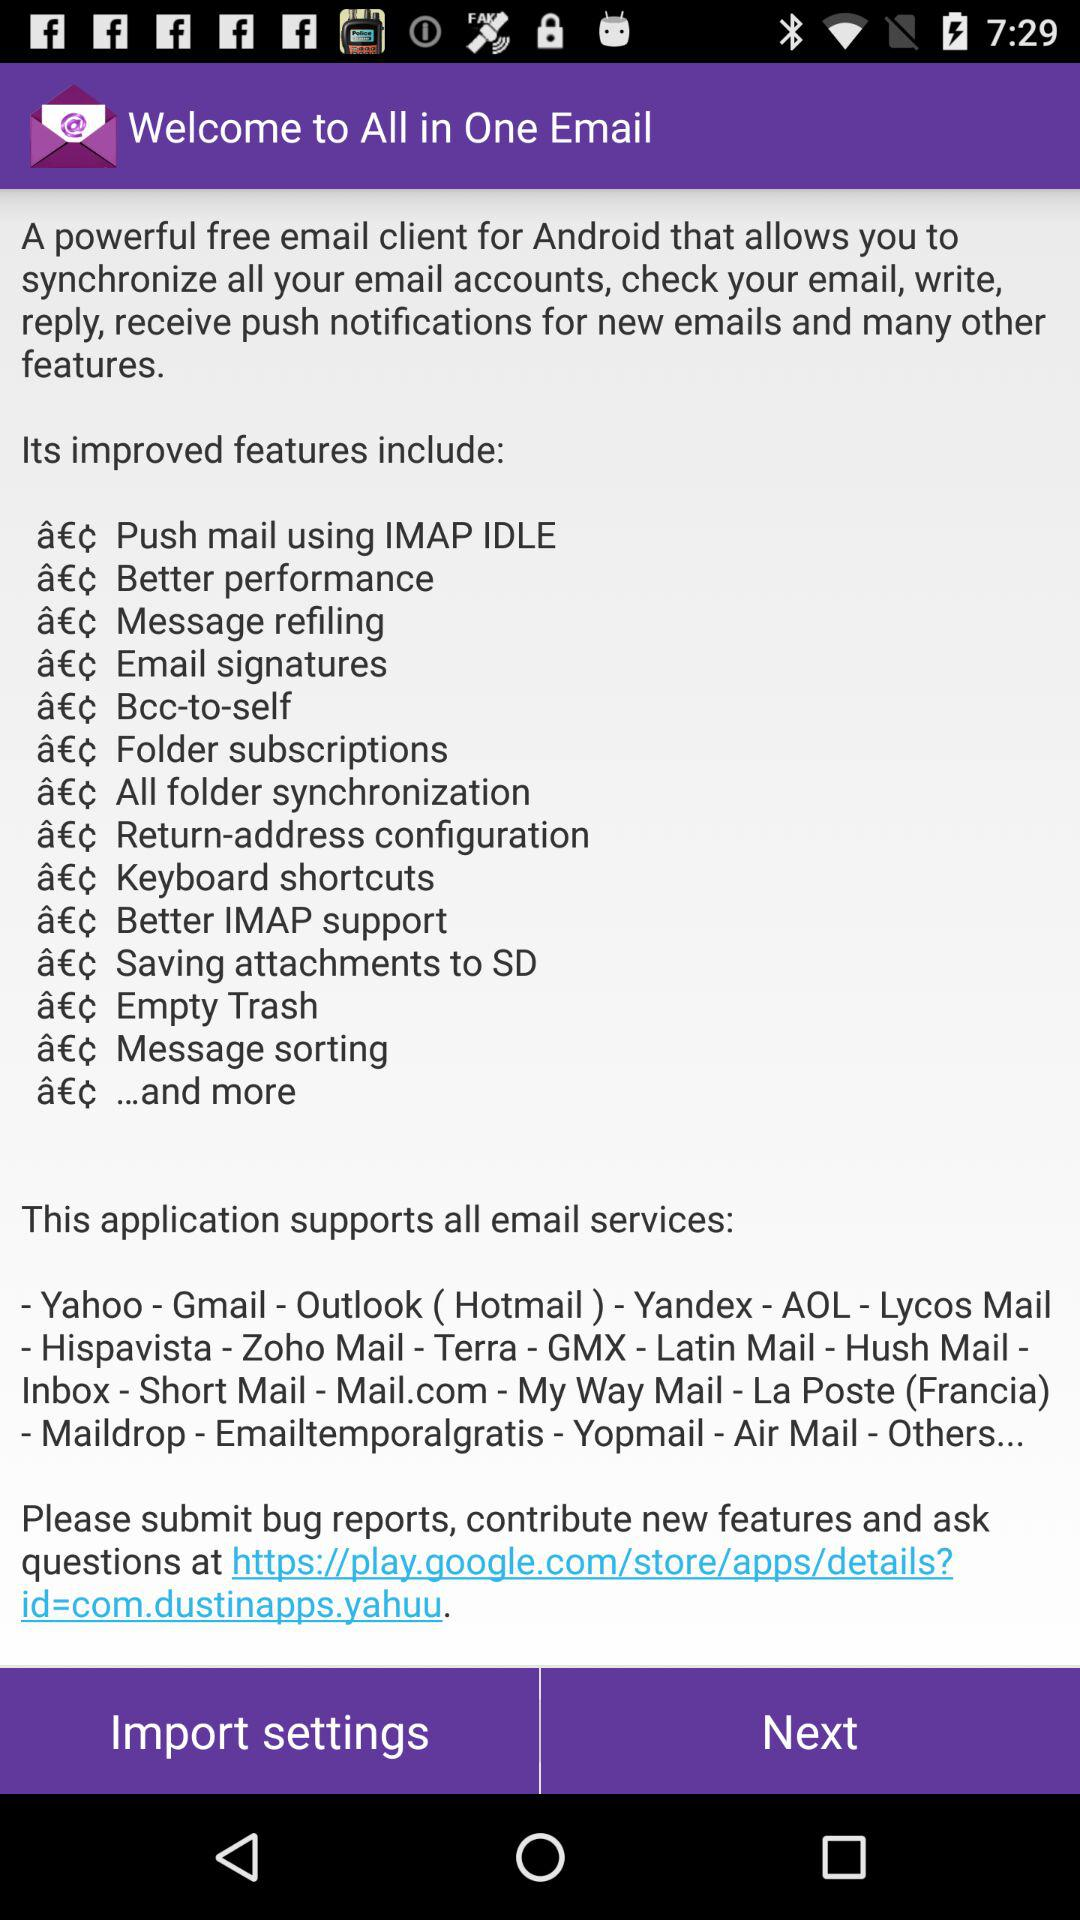Which settings can be imported?
When the provided information is insufficient, respond with <no answer>. <no answer> 